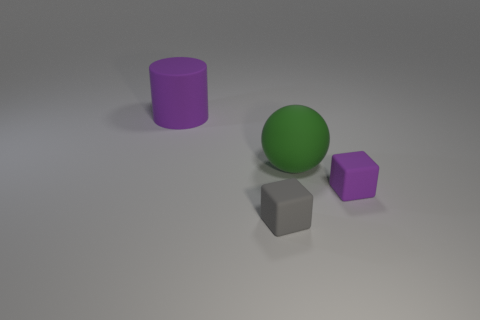There is a object that is behind the big green sphere; does it have the same color as the block right of the big green matte object?
Ensure brevity in your answer.  Yes. What shape is the purple rubber object on the right side of the purple matte object that is behind the purple object on the right side of the large cylinder?
Ensure brevity in your answer.  Cube. There is a matte thing that is both in front of the big green sphere and behind the tiny gray matte thing; what is its shape?
Keep it short and to the point. Cube. What number of large balls are right of the tiny thing in front of the purple object on the right side of the large purple cylinder?
Provide a short and direct response. 1. There is another object that is the same shape as the small purple object; what is its size?
Your response must be concise. Small. Is the material of the object that is to the right of the green matte sphere the same as the green sphere?
Provide a short and direct response. Yes. The other small matte object that is the same shape as the small gray thing is what color?
Provide a short and direct response. Purple. How many other things are there of the same color as the large ball?
Provide a succinct answer. 0. There is a large object to the left of the large green matte ball; does it have the same shape as the small rubber thing that is right of the gray matte cube?
Your response must be concise. No. What number of spheres are large brown matte things or gray rubber things?
Your response must be concise. 0. 